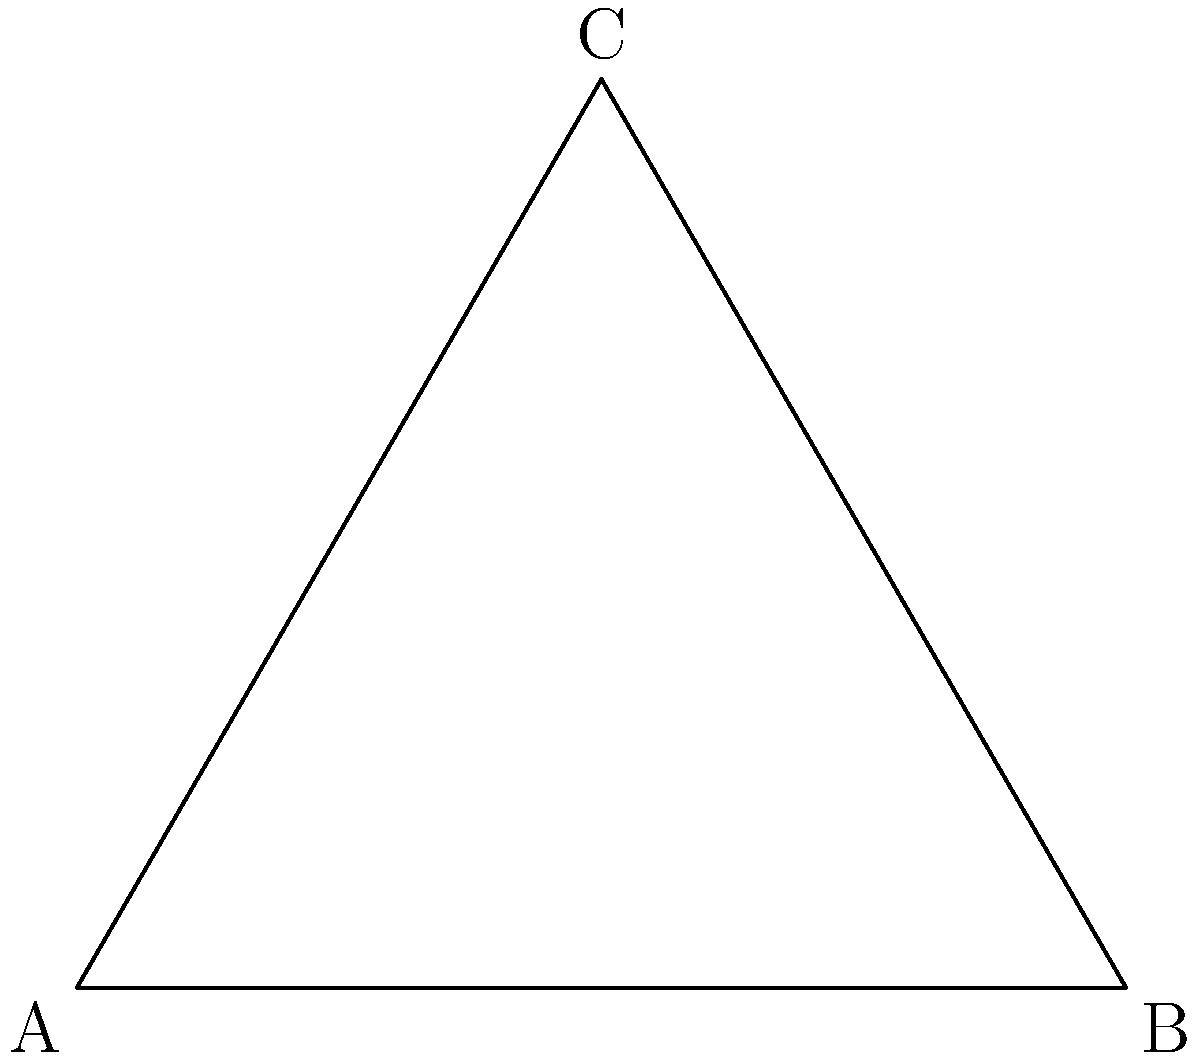In a case involving conflicting eyewitness testimonies, two witnesses observed an event from different positions represented by the blue and red circles in the diagram. The event occurred at point C. Given that visual perception can be affected by distance and angle, which witness's testimony should be considered more reliable, and why? To determine which witness's testimony is more reliable, we need to consider the following factors:

1. Distance from the event:
   - Witness 1 (blue circle): Distance = AC
   - Witness 2 (red circle): Distance = BC

2. Angle of view:
   - Witness 1: Angle CAB
   - Witness 2: Angle CBA

3. Triangle properties:
   The triangle is equilateral, meaning all sides are equal and all angles are 60°.

Step-by-step analysis:
1. Distances:
   AC = BC (equilateral triangle property)
   This means both witnesses are equidistant from the event.

2. Angles of view:
   Angle CAB = Angle CBA = 60° (equilateral triangle property)
   This means both witnesses have the same angle of view.

3. Reliability factors:
   - Distance affects visual acuity: closer observers generally provide more accurate details.
   - Angle of view affects perspective: direct line of sight (smaller angles) generally provides better observations.

4. Legal implications:
   In this case, both witnesses have equal distances and angles of view to the event. This means their testimonies should be considered equally reliable from a visual perspective.

5. Additional considerations:
   Other factors such as lighting conditions, obstructions, or individual visual acuity might affect reliability but are not represented in this diagram.
Answer: Equally reliable 